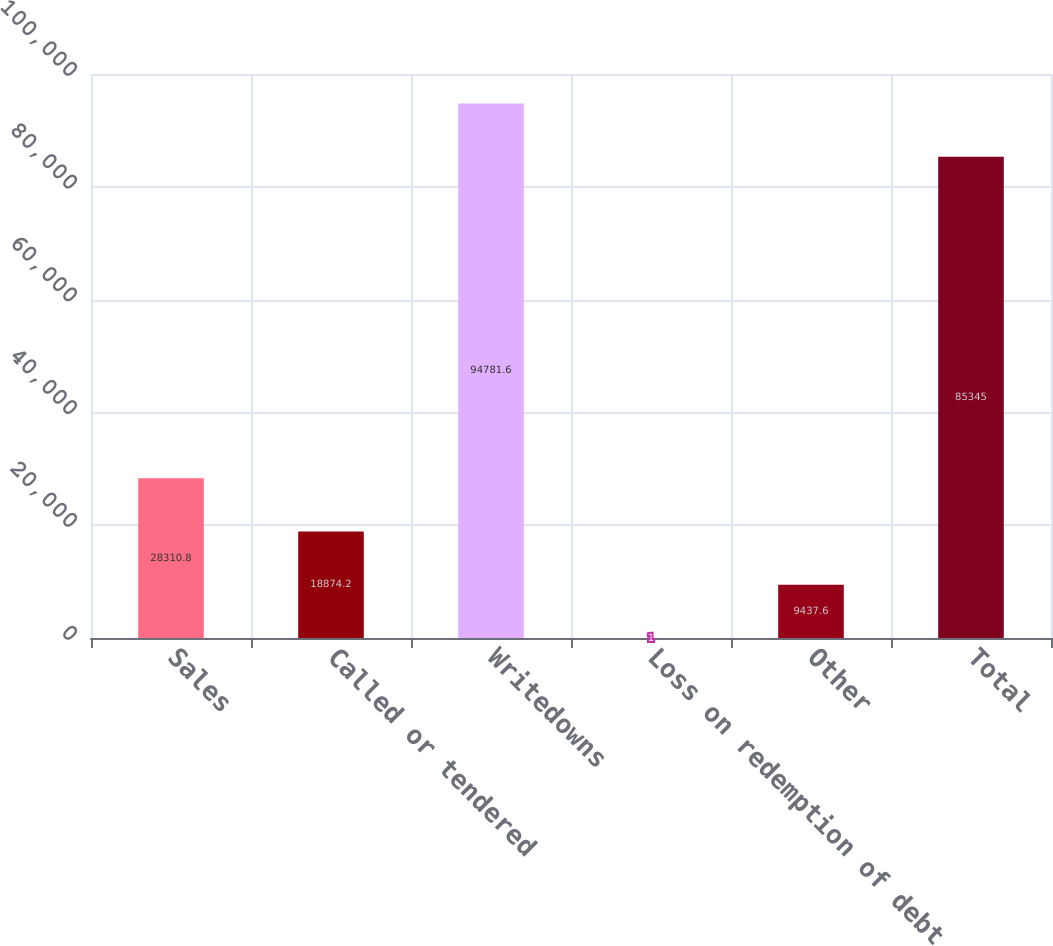<chart> <loc_0><loc_0><loc_500><loc_500><bar_chart><fcel>Sales<fcel>Called or tendered<fcel>Writedowns<fcel>Loss on redemption of debt<fcel>Other<fcel>Total<nl><fcel>28310.8<fcel>18874.2<fcel>94781.6<fcel>1<fcel>9437.6<fcel>85345<nl></chart> 